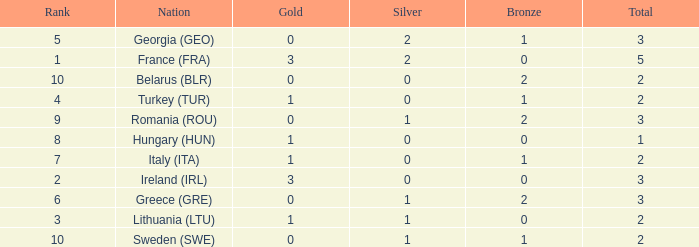What's the total when the gold is less than 0 and silver is less than 1? None. 